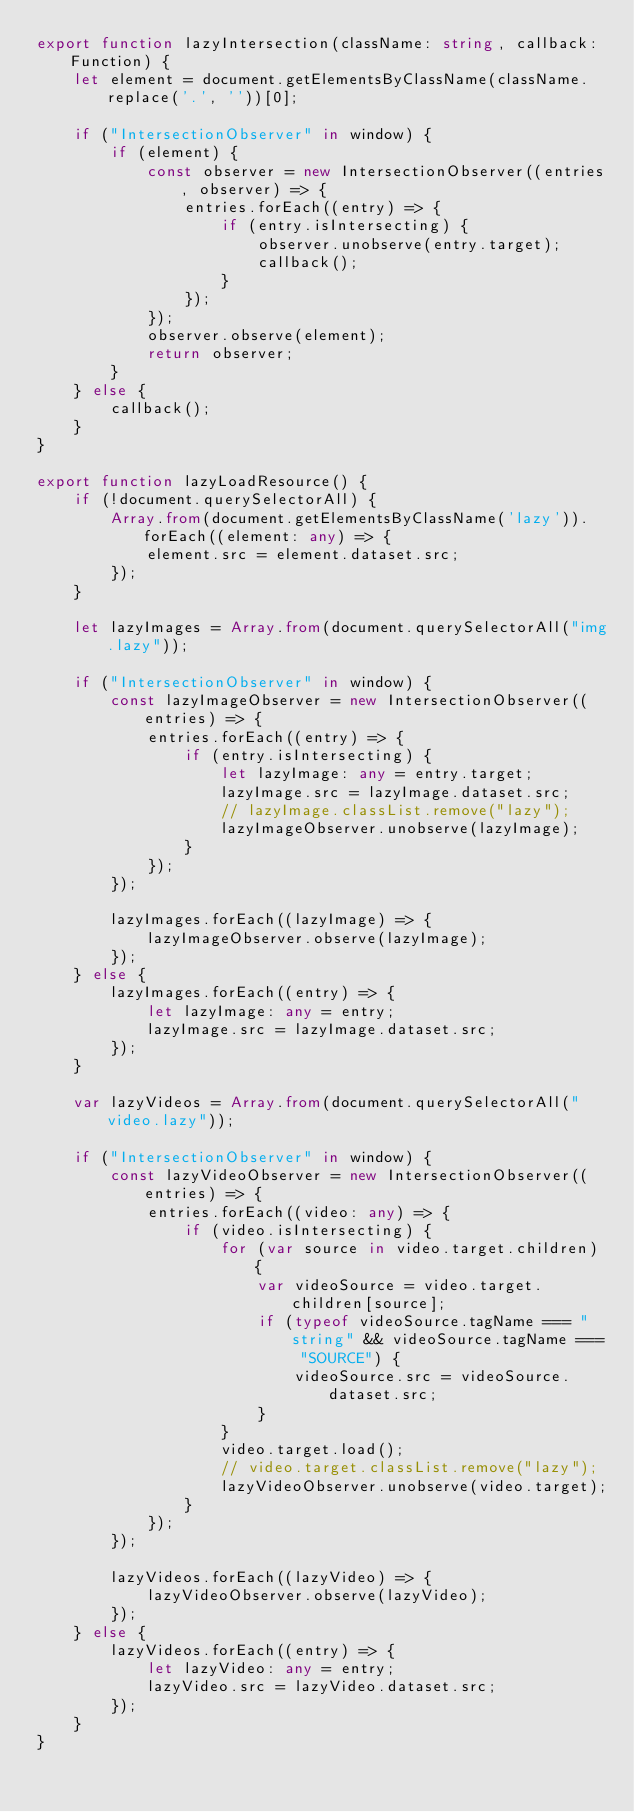Convert code to text. <code><loc_0><loc_0><loc_500><loc_500><_TypeScript_>export function lazyIntersection(className: string, callback: Function) {
    let element = document.getElementsByClassName(className.replace('.', ''))[0];

    if ("IntersectionObserver" in window) {
        if (element) {
            const observer = new IntersectionObserver((entries, observer) => {
                entries.forEach((entry) => {
                    if (entry.isIntersecting) {
                        observer.unobserve(entry.target);
                        callback();
                    }
                });
            });
            observer.observe(element);
            return observer;
        }
    } else {
        callback();
    }
}

export function lazyLoadResource() {
    if (!document.querySelectorAll) {
        Array.from(document.getElementsByClassName('lazy')).forEach((element: any) => {
            element.src = element.dataset.src;
        });
    }

    let lazyImages = Array.from(document.querySelectorAll("img.lazy"));

    if ("IntersectionObserver" in window) {
        const lazyImageObserver = new IntersectionObserver((entries) => {
            entries.forEach((entry) => {
                if (entry.isIntersecting) {
                    let lazyImage: any = entry.target;
                    lazyImage.src = lazyImage.dataset.src;
                    // lazyImage.classList.remove("lazy");
                    lazyImageObserver.unobserve(lazyImage);
                }
            });
        });

        lazyImages.forEach((lazyImage) => {
            lazyImageObserver.observe(lazyImage);
        });
    } else {
        lazyImages.forEach((entry) => {
            let lazyImage: any = entry;
            lazyImage.src = lazyImage.dataset.src;
        });
    }

    var lazyVideos = Array.from(document.querySelectorAll("video.lazy"));

    if ("IntersectionObserver" in window) {
        const lazyVideoObserver = new IntersectionObserver((entries) => {
            entries.forEach((video: any) => {
                if (video.isIntersecting) {
                    for (var source in video.target.children) {
                        var videoSource = video.target.children[source];
                        if (typeof videoSource.tagName === "string" && videoSource.tagName === "SOURCE") {
                            videoSource.src = videoSource.dataset.src;
                        }
                    }
                    video.target.load();
                    // video.target.classList.remove("lazy");
                    lazyVideoObserver.unobserve(video.target);
                }
            });
        });

        lazyVideos.forEach((lazyVideo) => {
            lazyVideoObserver.observe(lazyVideo);
        });
    } else {
        lazyVideos.forEach((entry) => {
            let lazyVideo: any = entry;
            lazyVideo.src = lazyVideo.dataset.src;
        });
    }
}</code> 